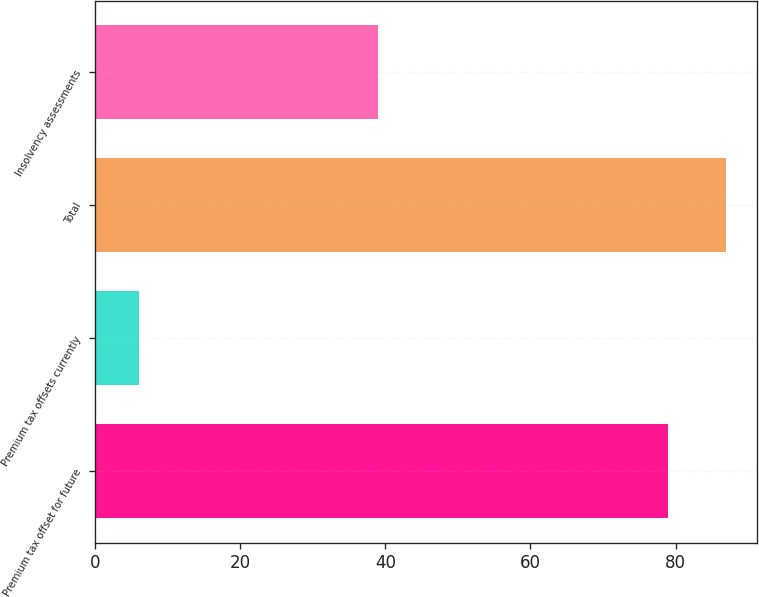Convert chart to OTSL. <chart><loc_0><loc_0><loc_500><loc_500><bar_chart><fcel>Premium tax offset for future<fcel>Premium tax offsets currently<fcel>Total<fcel>Insolvency assessments<nl><fcel>79<fcel>6<fcel>86.9<fcel>39<nl></chart> 